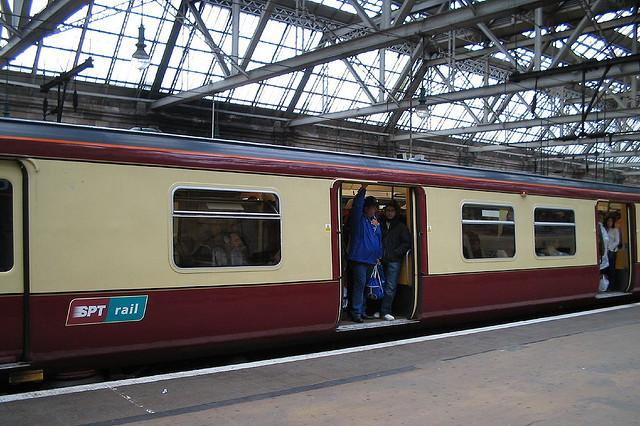What is the person wearing the blue coat about to do? Please explain your reasoning. get off. He's leaning forward in the way of the doors as he's about to leave 